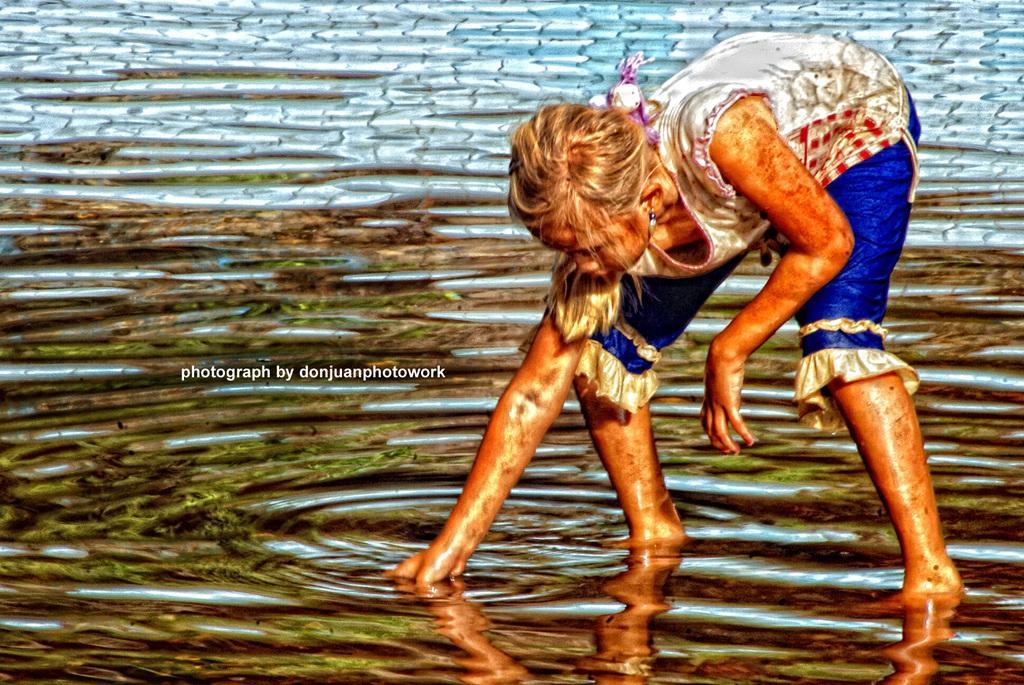In one or two sentences, can you explain what this image depicts? In this image I can see water and a girl in the front. I can see she is wearing white colour top and blue pant. On the left side of this image I can see a watermark. 